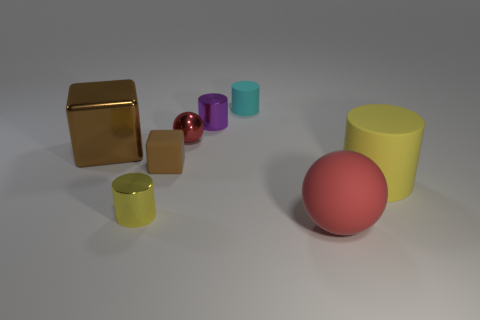There is a tiny cube; what number of things are in front of it?
Give a very brief answer. 3. What is the large yellow cylinder made of?
Offer a terse response. Rubber. What is the color of the thing that is right of the red thing in front of the cylinder on the left side of the small brown matte cube?
Ensure brevity in your answer.  Yellow. How many green metal cylinders are the same size as the brown metal thing?
Provide a short and direct response. 0. The big thing left of the small cyan rubber cylinder is what color?
Your answer should be very brief. Brown. How many other things are the same size as the matte ball?
Provide a succinct answer. 2. There is a cylinder that is both left of the tiny cyan object and behind the yellow shiny thing; what is its size?
Your response must be concise. Small. There is a shiny ball; is it the same color as the small thing that is in front of the big yellow matte cylinder?
Provide a succinct answer. No. Is there a tiny object that has the same shape as the big red matte thing?
Your answer should be very brief. Yes. What number of objects are either cyan rubber objects or large matte things behind the rubber sphere?
Give a very brief answer. 2. 